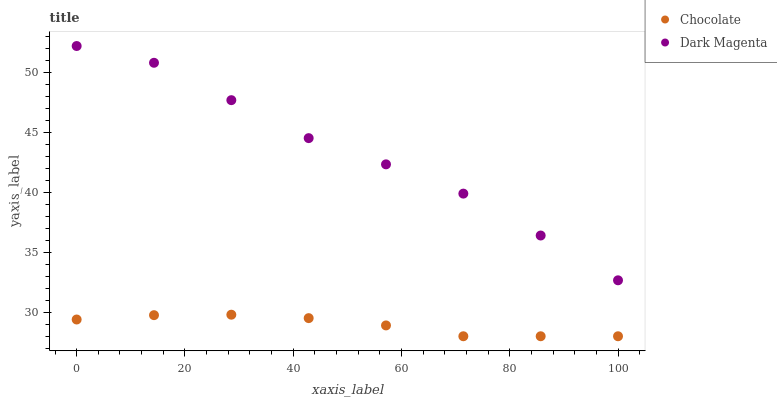Does Chocolate have the minimum area under the curve?
Answer yes or no. Yes. Does Dark Magenta have the maximum area under the curve?
Answer yes or no. Yes. Does Chocolate have the maximum area under the curve?
Answer yes or no. No. Is Chocolate the smoothest?
Answer yes or no. Yes. Is Dark Magenta the roughest?
Answer yes or no. Yes. Is Chocolate the roughest?
Answer yes or no. No. Does Chocolate have the lowest value?
Answer yes or no. Yes. Does Dark Magenta have the highest value?
Answer yes or no. Yes. Does Chocolate have the highest value?
Answer yes or no. No. Is Chocolate less than Dark Magenta?
Answer yes or no. Yes. Is Dark Magenta greater than Chocolate?
Answer yes or no. Yes. Does Chocolate intersect Dark Magenta?
Answer yes or no. No. 